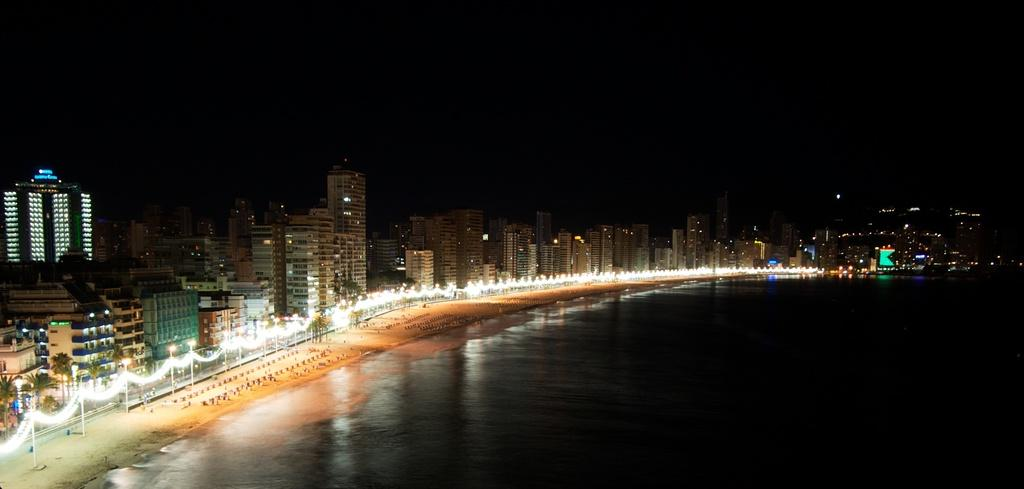What can be seen in the image that is related to water? There is water visible in the image. What structures are present in the image that provide light? Light poles are present in the image. What type of pathway is visible in the image? There is a road in the image. What type of buildings can be seen in the image? Tower buildings are visible in the image. What type of vegetation is present in the image? Trees are present in the image. How would you describe the sky in the background of the image? The sky in the background is dark. What type of steel is used to construct the lunch in the image? There is no lunch present in the image, and therefore no steel construction can be observed. What type of light is emitted from the trees in the image? There is no light emitted from the trees in the image; they are simply vegetation. 